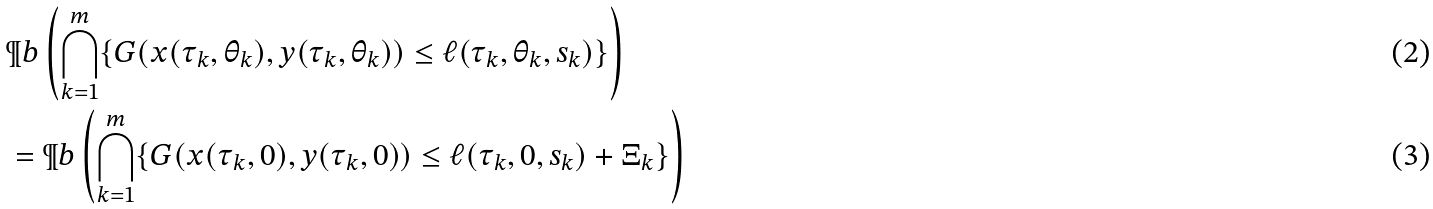Convert formula to latex. <formula><loc_0><loc_0><loc_500><loc_500>& \P b \left ( \bigcap _ { k = 1 } ^ { m } \{ G ( x ( \tau _ { k } , \theta _ { k } ) , y ( \tau _ { k } , \theta _ { k } ) ) \leq \ell ( \tau _ { k } , \theta _ { k } , s _ { k } ) \} \right ) \\ & = \P b \left ( \bigcap _ { k = 1 } ^ { m } \{ G ( x ( \tau _ { k } , 0 ) , y ( \tau _ { k } , 0 ) ) \leq \ell ( \tau _ { k } , 0 , s _ { k } ) + \Xi _ { k } \} \right )</formula> 